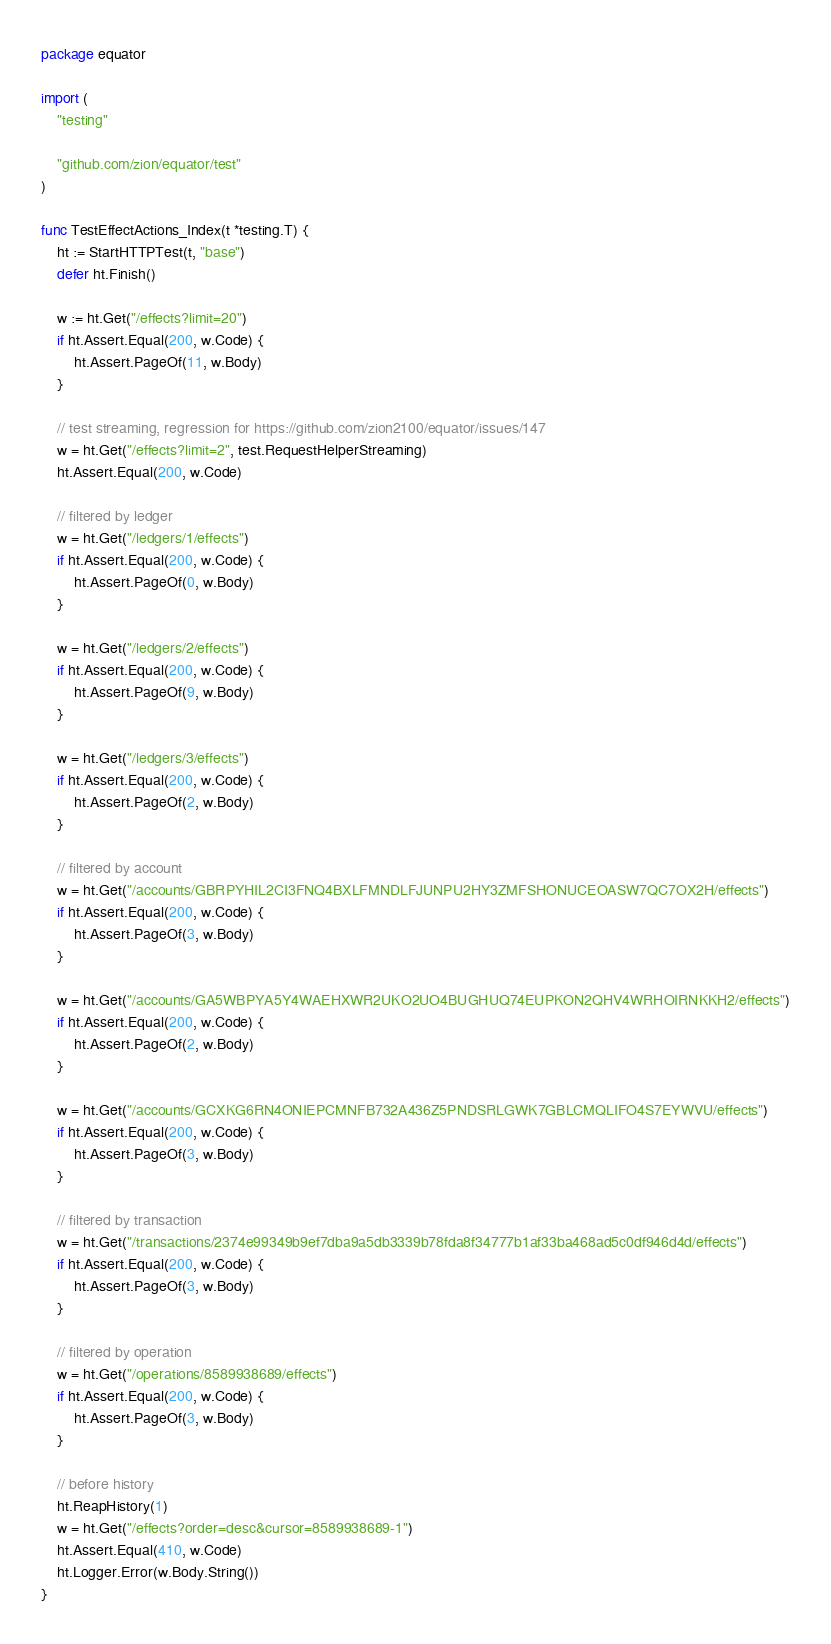Convert code to text. <code><loc_0><loc_0><loc_500><loc_500><_Go_>package equator

import (
	"testing"

	"github.com/zion/equator/test"
)

func TestEffectActions_Index(t *testing.T) {
	ht := StartHTTPTest(t, "base")
	defer ht.Finish()

	w := ht.Get("/effects?limit=20")
	if ht.Assert.Equal(200, w.Code) {
		ht.Assert.PageOf(11, w.Body)
	}

	// test streaming, regression for https://github.com/zion2100/equator/issues/147
	w = ht.Get("/effects?limit=2", test.RequestHelperStreaming)
	ht.Assert.Equal(200, w.Code)

	// filtered by ledger
	w = ht.Get("/ledgers/1/effects")
	if ht.Assert.Equal(200, w.Code) {
		ht.Assert.PageOf(0, w.Body)
	}

	w = ht.Get("/ledgers/2/effects")
	if ht.Assert.Equal(200, w.Code) {
		ht.Assert.PageOf(9, w.Body)
	}

	w = ht.Get("/ledgers/3/effects")
	if ht.Assert.Equal(200, w.Code) {
		ht.Assert.PageOf(2, w.Body)
	}

	// filtered by account
	w = ht.Get("/accounts/GBRPYHIL2CI3FNQ4BXLFMNDLFJUNPU2HY3ZMFSHONUCEOASW7QC7OX2H/effects")
	if ht.Assert.Equal(200, w.Code) {
		ht.Assert.PageOf(3, w.Body)
	}

	w = ht.Get("/accounts/GA5WBPYA5Y4WAEHXWR2UKO2UO4BUGHUQ74EUPKON2QHV4WRHOIRNKKH2/effects")
	if ht.Assert.Equal(200, w.Code) {
		ht.Assert.PageOf(2, w.Body)
	}

	w = ht.Get("/accounts/GCXKG6RN4ONIEPCMNFB732A436Z5PNDSRLGWK7GBLCMQLIFO4S7EYWVU/effects")
	if ht.Assert.Equal(200, w.Code) {
		ht.Assert.PageOf(3, w.Body)
	}

	// filtered by transaction
	w = ht.Get("/transactions/2374e99349b9ef7dba9a5db3339b78fda8f34777b1af33ba468ad5c0df946d4d/effects")
	if ht.Assert.Equal(200, w.Code) {
		ht.Assert.PageOf(3, w.Body)
	}

	// filtered by operation
	w = ht.Get("/operations/8589938689/effects")
	if ht.Assert.Equal(200, w.Code) {
		ht.Assert.PageOf(3, w.Body)
	}

	// before history
	ht.ReapHistory(1)
	w = ht.Get("/effects?order=desc&cursor=8589938689-1")
	ht.Assert.Equal(410, w.Code)
	ht.Logger.Error(w.Body.String())
}
</code> 